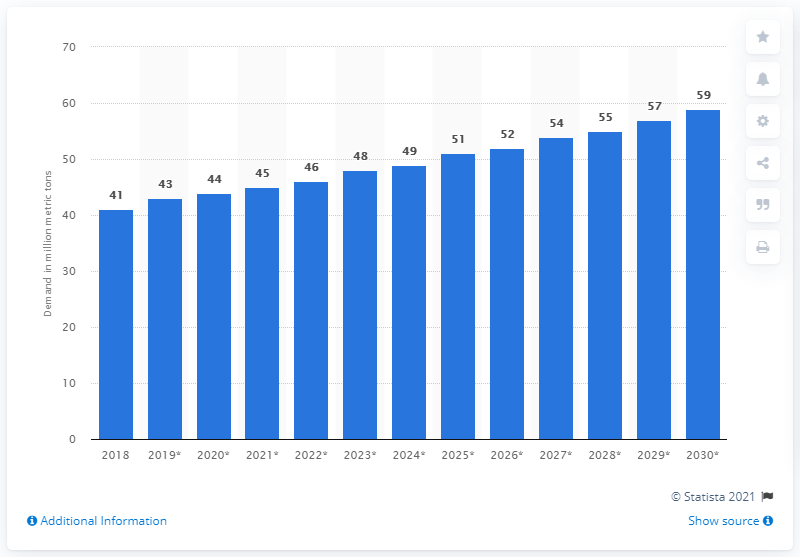List a handful of essential elements in this visual. In 2018, the total demand for paper worldwide was approximately 41 million metric tons. The global demand for fluff and tissue is forecasted to increase significantly in the next decade. 